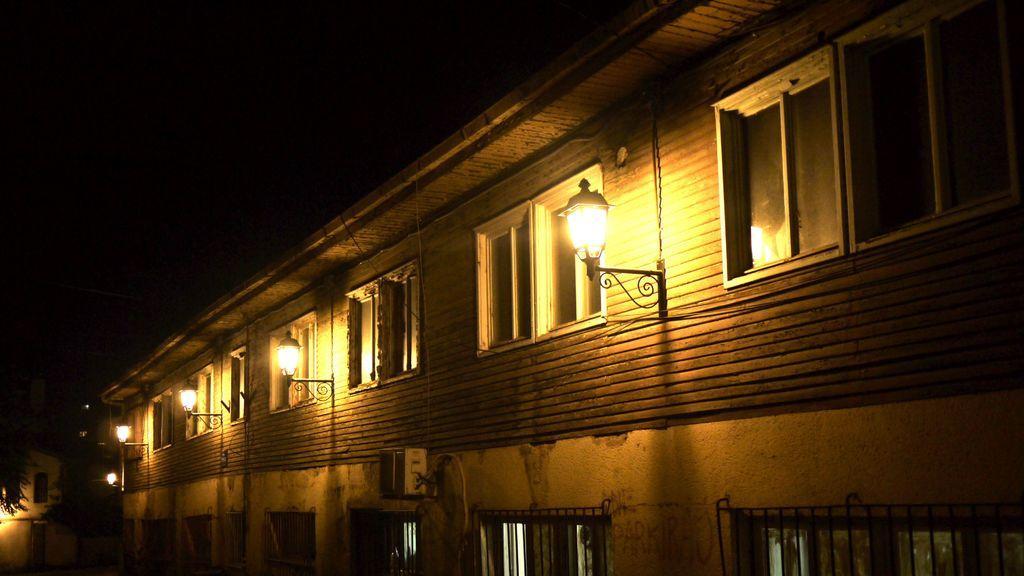Describe this image in one or two sentences. In the picture we can see a building with windows and besides, we can see stands and lights to it and in the background we can see dark. 